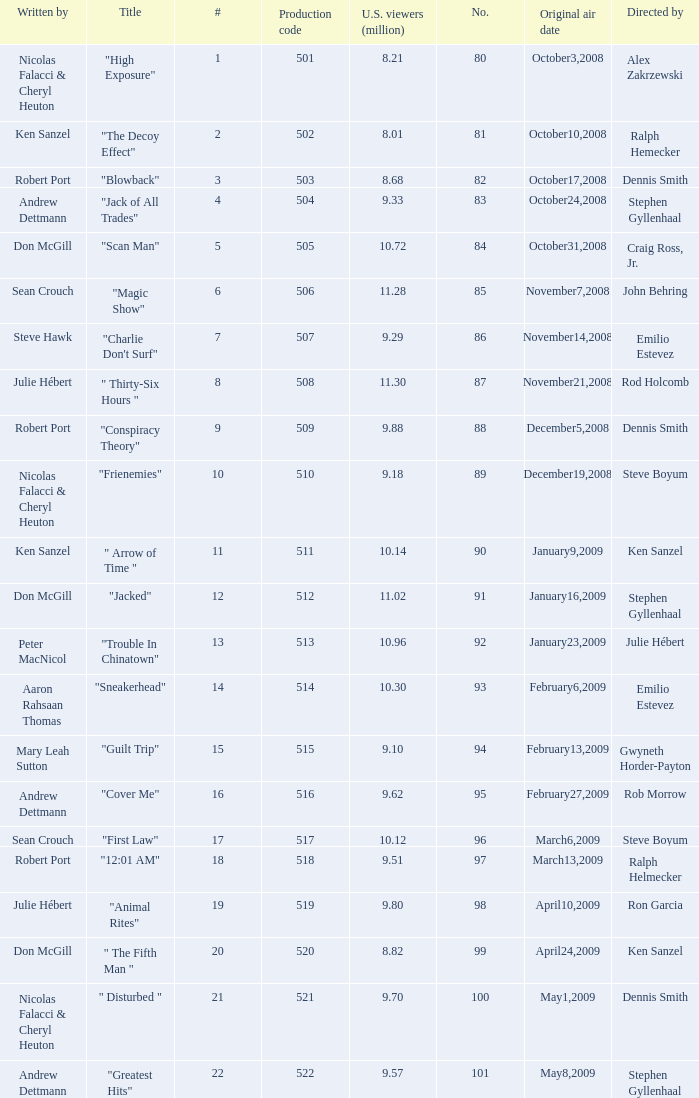What episode had 10.14 million viewers (U.S.)? 11.0. 